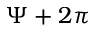<formula> <loc_0><loc_0><loc_500><loc_500>\Psi + 2 \pi</formula> 